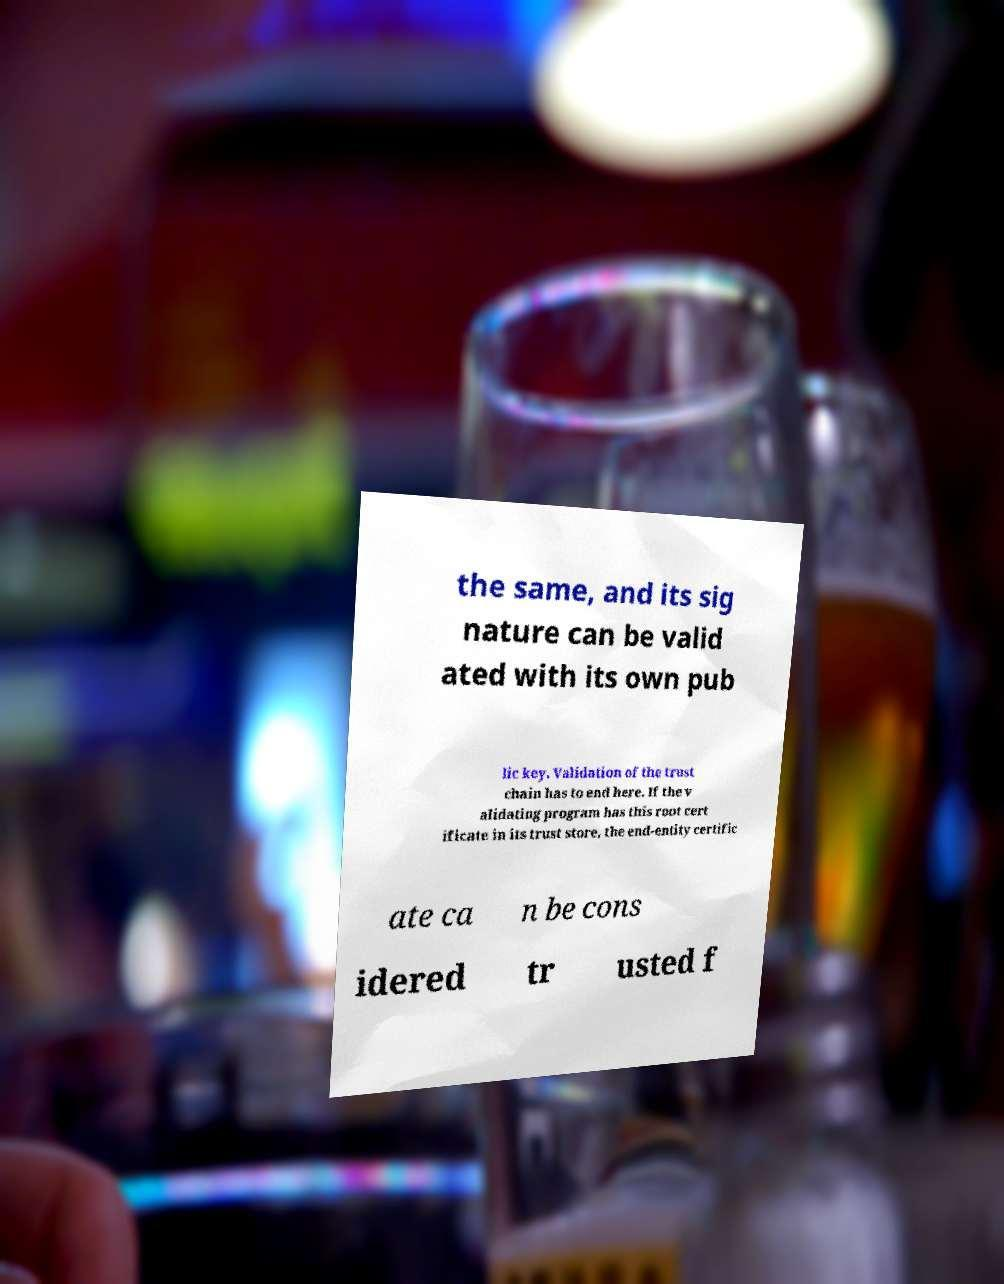For documentation purposes, I need the text within this image transcribed. Could you provide that? the same, and its sig nature can be valid ated with its own pub lic key. Validation of the trust chain has to end here. If the v alidating program has this root cert ificate in its trust store, the end-entity certific ate ca n be cons idered tr usted f 